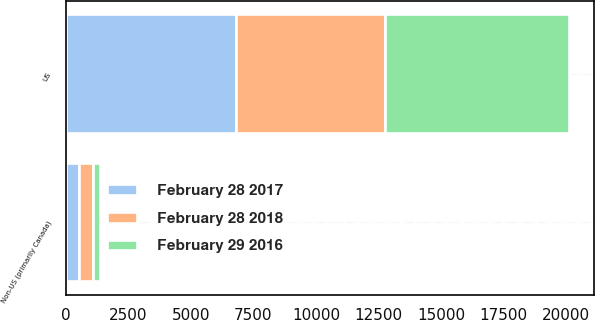Convert chart. <chart><loc_0><loc_0><loc_500><loc_500><stacked_bar_chart><ecel><fcel>US<fcel>Non-US (primarily Canada)<nl><fcel>February 29 2016<fcel>7330.1<fcel>254.9<nl><fcel>February 28 2017<fcel>6807.7<fcel>523.8<nl><fcel>February 28 2018<fcel>5960.9<fcel>587.5<nl></chart> 